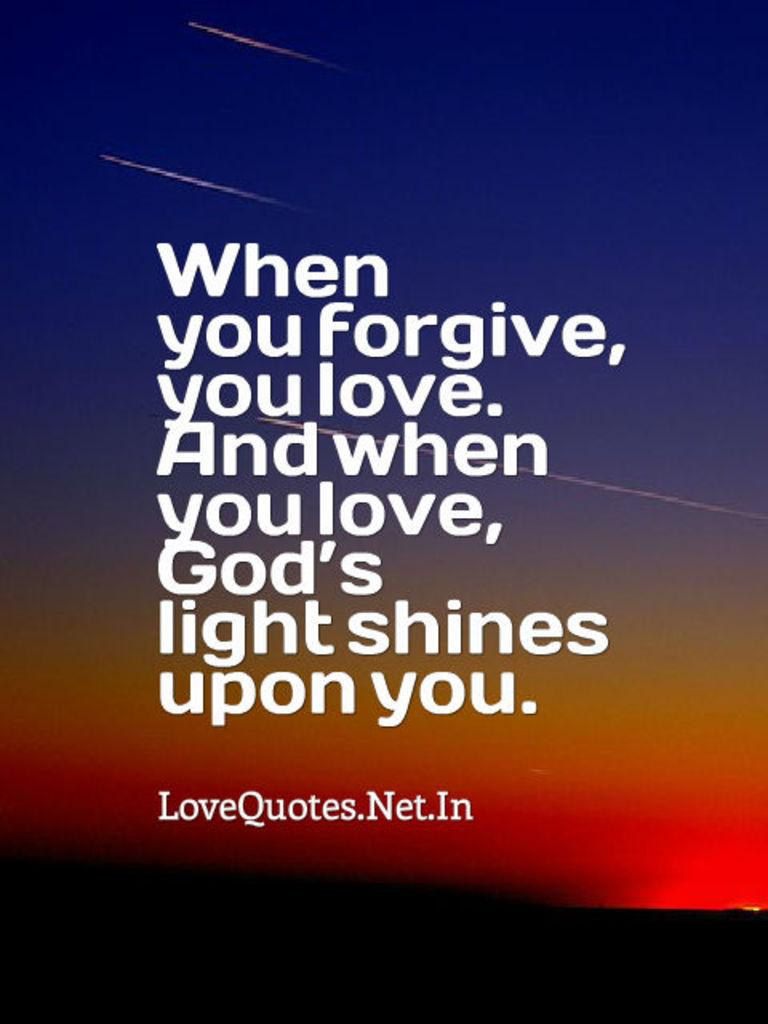<image>
Present a compact description of the photo's key features. In front of a color background the word love is mentioned. 